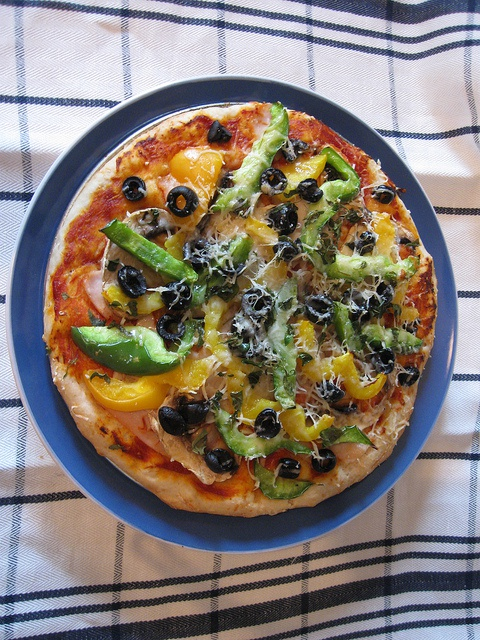Describe the objects in this image and their specific colors. I can see a pizza in black, brown, olive, and maroon tones in this image. 